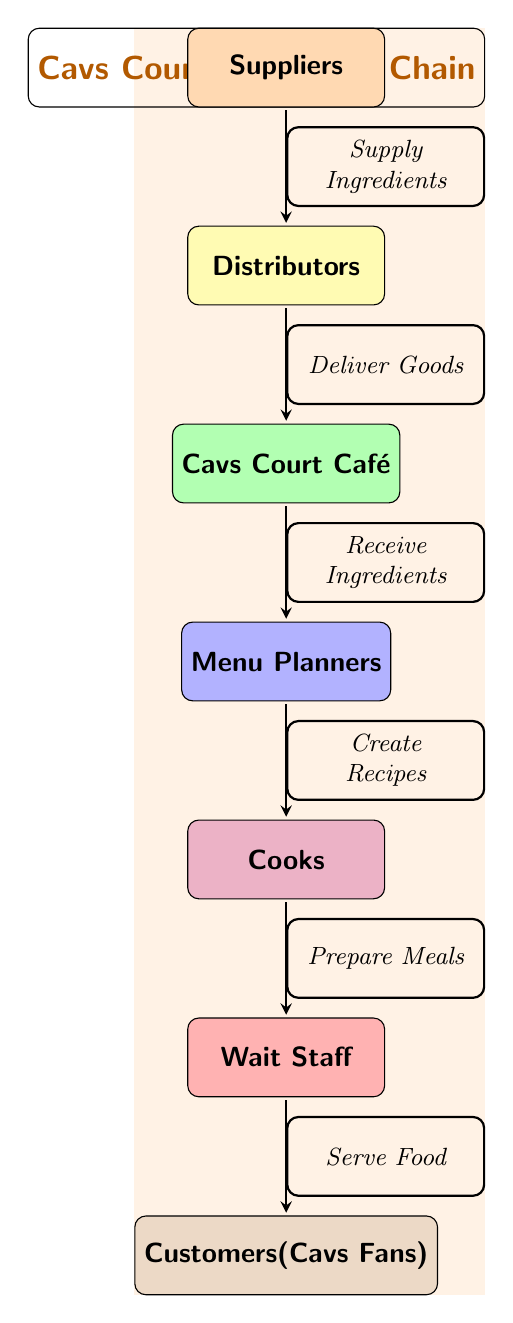What is the top node in the food chain? The top node in the food chain represents the final outcome or recipient of the goods, which in this case is the "Customers" or "Cavs Fans." The diagram showcases a flow starting from suppliers and culminating at the customers.
Answer: Customers (Cavs Fans) How many nodes are in the food chain? To determine the total number of nodes in the food chain, we can count each distinct element connected through arrows in the diagram. There are seven nodes: Suppliers, Distributors, Cavs Court Café, Menu Planners, Cooks, Wait Staff, and Customers.
Answer: 7 What action occurs between the Restaurant and the Menu Planners? The action established between the Restaurant and the Menu Planners is to "Receive Ingredients." This indicates that the restaurant obtains the ingredients supplied, which the menu planners utilize for their recipes.
Answer: Receive Ingredients Who serves the food to the customers? The node that is responsible for serving food to the customers is the "Wait Staff." This role wraps up the processes initiated earlier, culminating in the customers receiving their meals.
Answer: Wait Staff What do Menu Planners create in the food chain? The Menu Planners in the food chain are tasked with creating "Recipes." This function is pivotal to ensure that the food made aligns with the establishment's offerings and meets customers' preferences.
Answer: Recipes How does the food flow from Cooks to Customers? The food flows from Cooks to Customers through the Wait Staff, who are responsible for "Serve Food." Thus, the Cooks prepare meals that the Wait Staff then deliver to the Customers.
Answer: Serve Food What is the role of Distributors in the food chain? The Distributors in the food chain play the role of "Deliver Goods." They are responsible for transporting ingredients and supplies from Suppliers to the Restaurant, which is crucial for the food preparation process.
Answer: Deliver Goods What is the connection between Suppliers and Distributors? The connection between Suppliers and Distributors is characterized by the action "Supply Ingredients." This indicates that the Suppliers provide necessary materials that the Distributors must transport to the next stage.
Answer: Supply Ingredients What do Cooks prepare? Cooks prepare "Meals," which refers to the final food products that are made based on the recipes created by the Menu Planners. This step transforms raw ingredients into edible dishes ready for serving.
Answer: Meals 